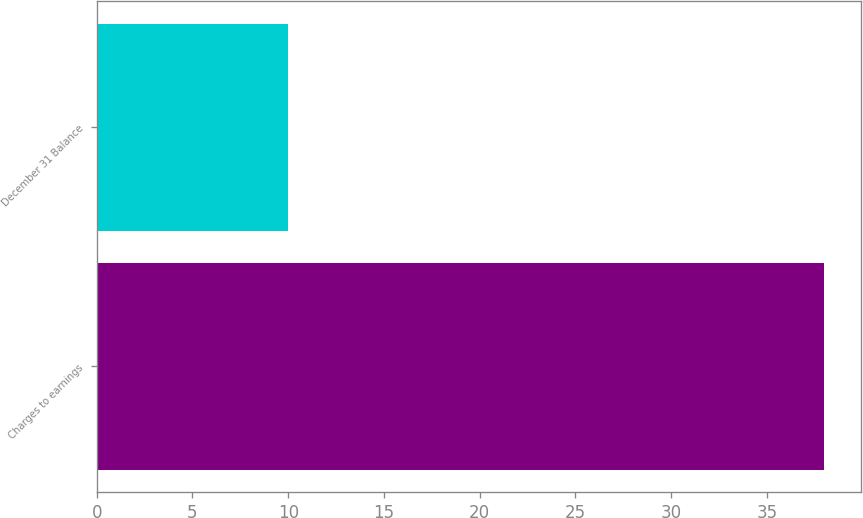Convert chart to OTSL. <chart><loc_0><loc_0><loc_500><loc_500><bar_chart><fcel>Charges to earnings<fcel>December 31 Balance<nl><fcel>38<fcel>10<nl></chart> 